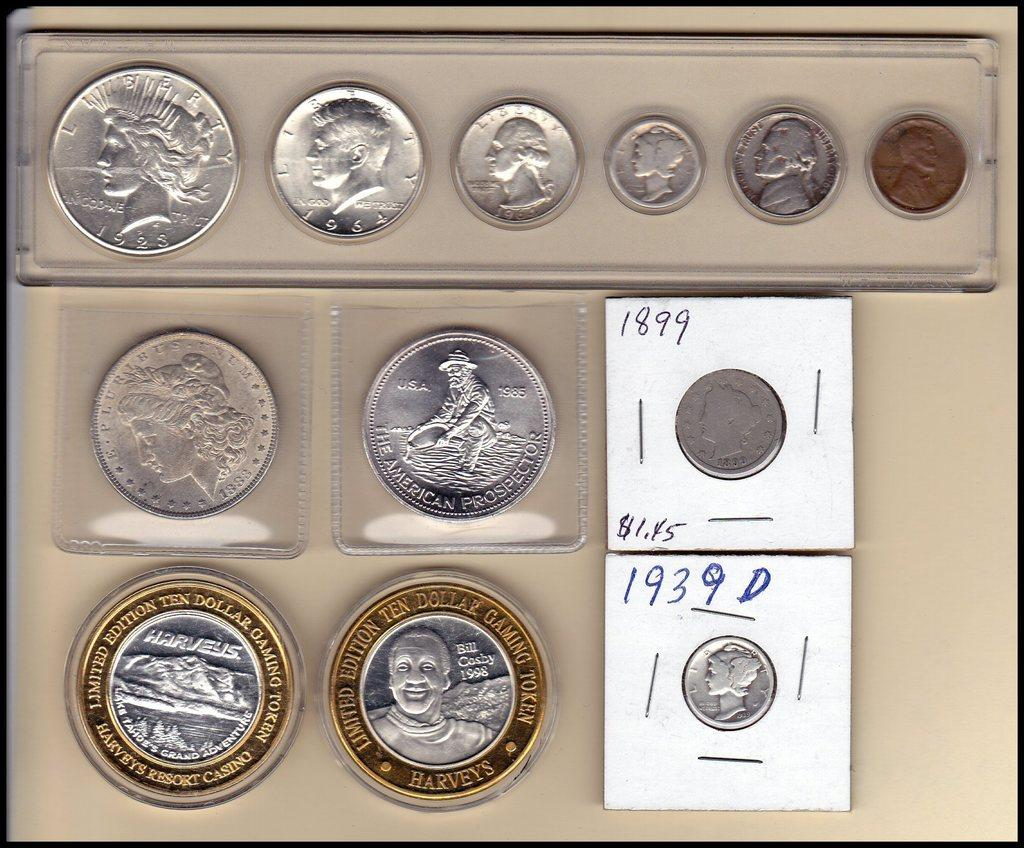<image>
Render a clear and concise summary of the photo. A coin collection featuring U.S. coins and a ten dollar token from Harveys. 